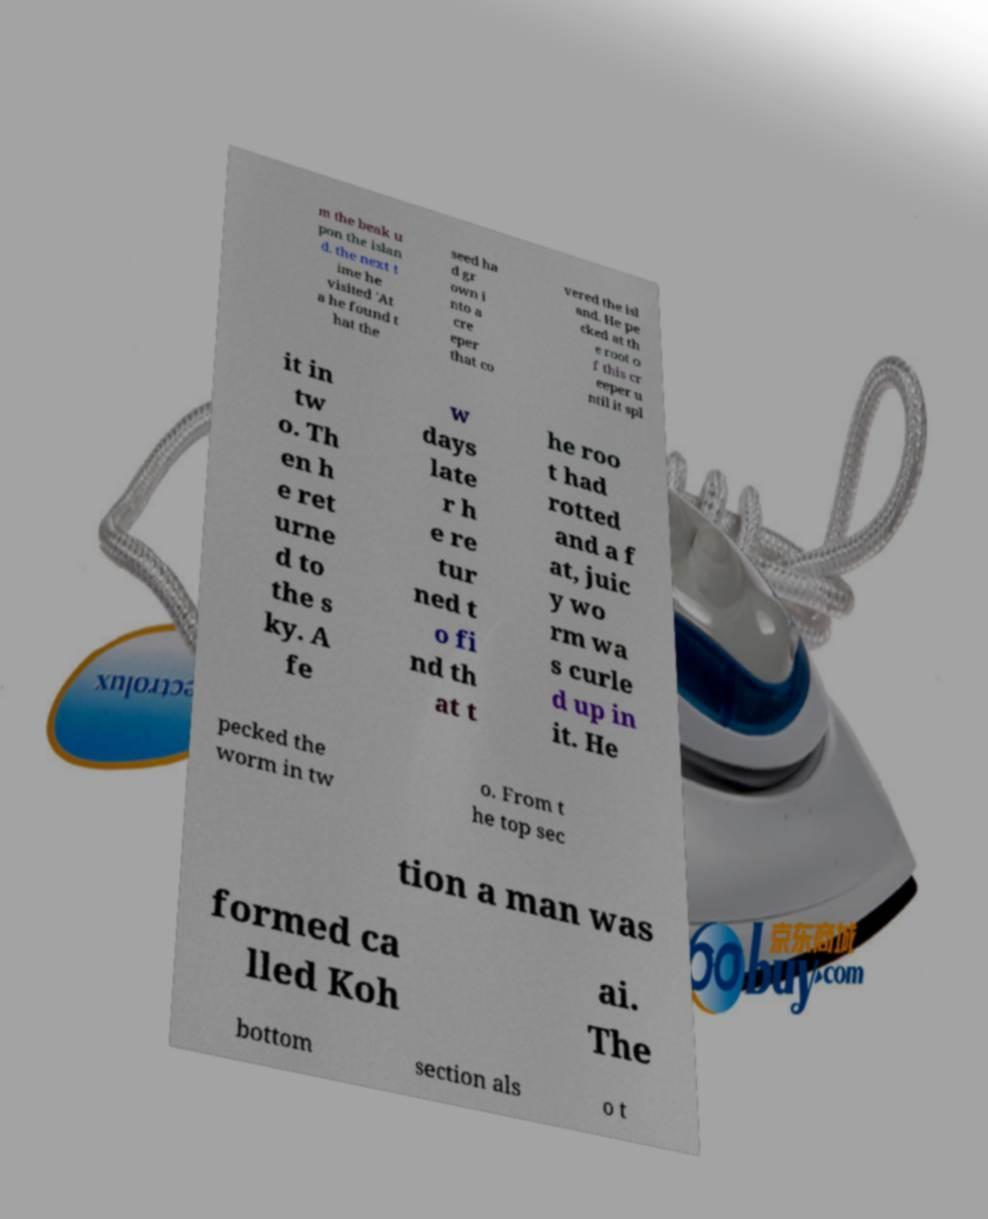I need the written content from this picture converted into text. Can you do that? m the beak u pon the islan d. the next t ime he visited 'At a he found t hat the seed ha d gr own i nto a cre eper that co vered the isl and. He pe cked at th e root o f this cr eeper u ntil it spl it in tw o. Th en h e ret urne d to the s ky. A fe w days late r h e re tur ned t o fi nd th at t he roo t had rotted and a f at, juic y wo rm wa s curle d up in it. He pecked the worm in tw o. From t he top sec tion a man was formed ca lled Koh ai. The bottom section als o t 